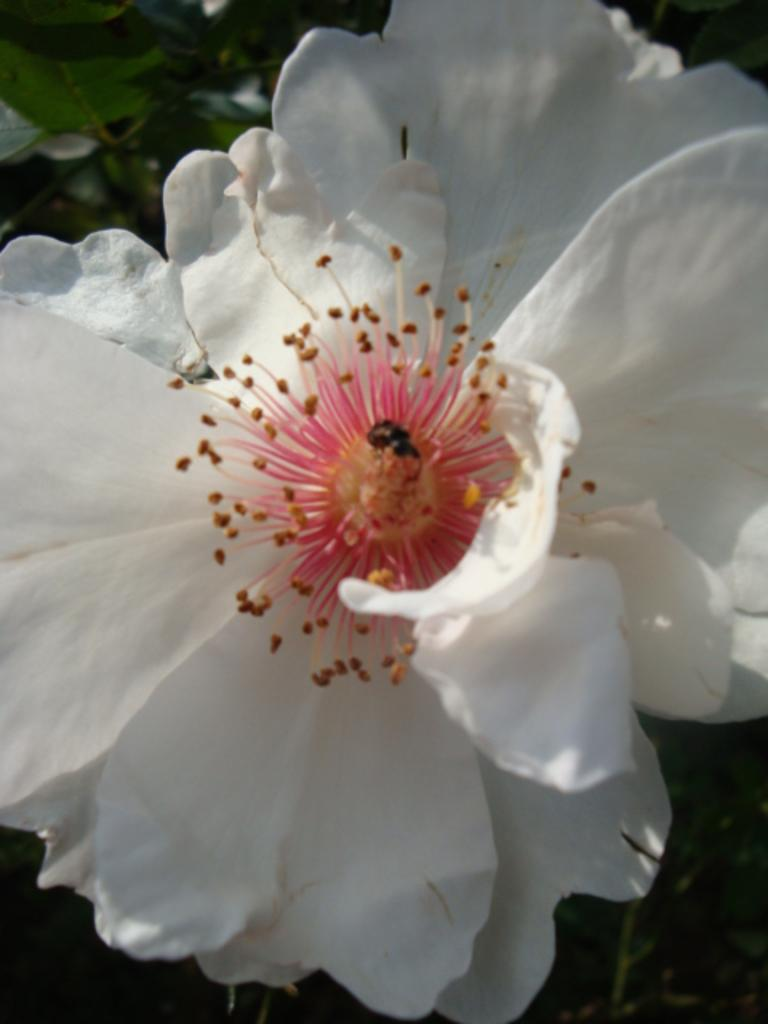Where was the image taken? The image was taken outdoors. What can be seen in the background of the image? There are plants in the background of the image. What is in the middle of the image? There is a floor in the middle of the image. What color is the floor? The floor is white in color. How many kittens are playing on the white floor in the image? There are no kittens present in the image. 